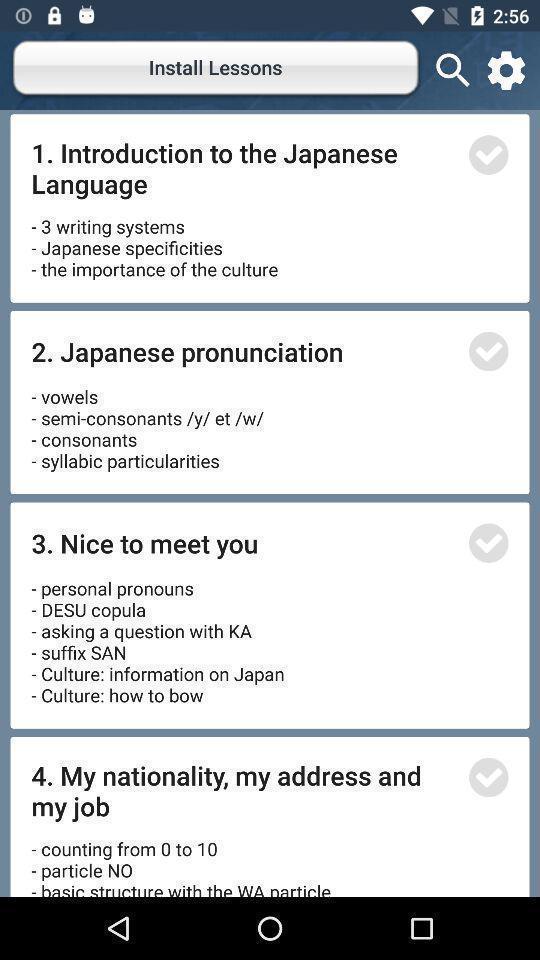Explain what's happening in this screen capture. Page displaying to install lessons in the app. 